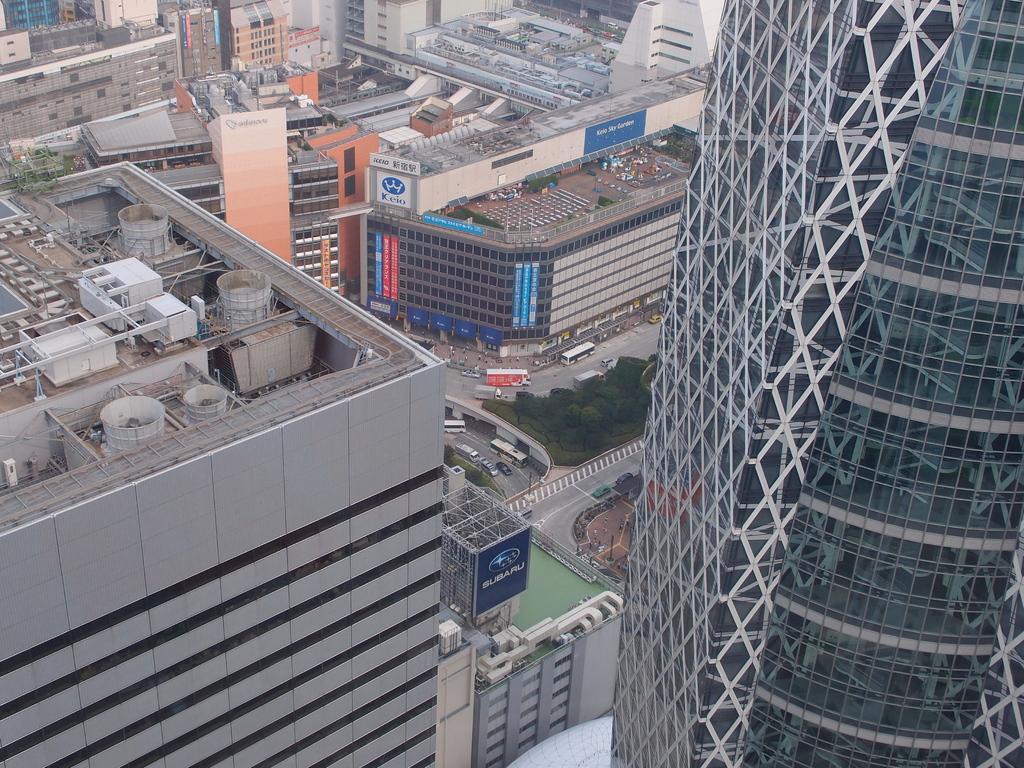Can you describe this image briefly? In this picture we can see buildings, boards, trees, vehicles on the road and objects. 